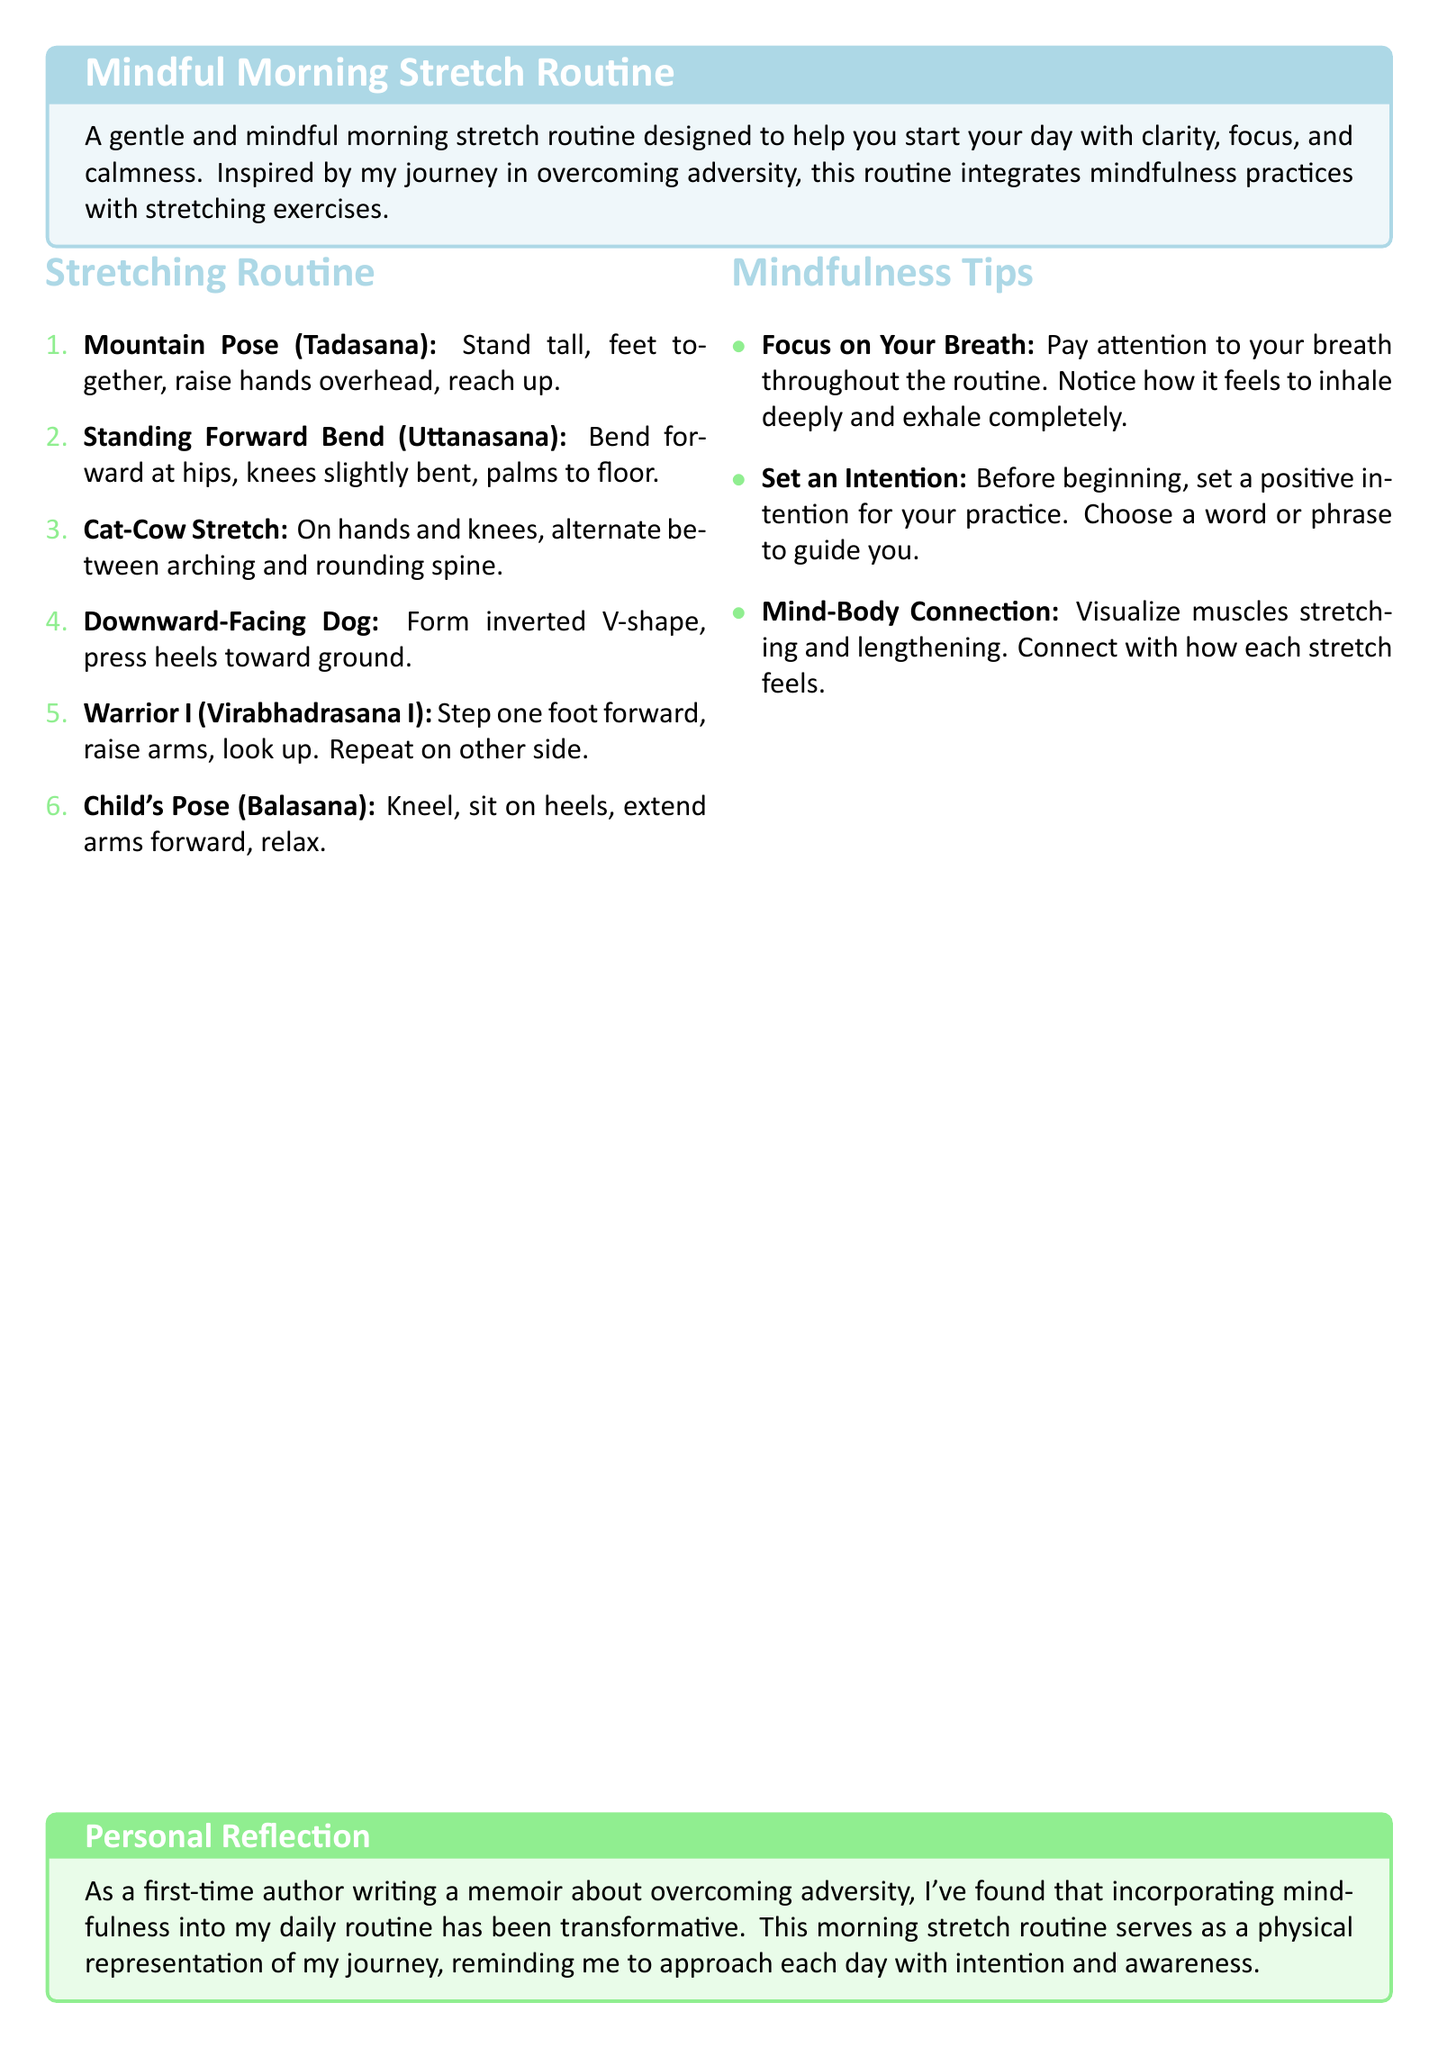What is the title of the routine? The title of the routine is presented in the tcolorbox at the beginning of the document.
Answer: Mindful Morning Stretch Routine How many stretches are included in the routine? The number of stretches is given in the enumerated list of the stretching routine.
Answer: Six What is the first stretch listed in the routine? The first stretch listed corresponds to the first item in the numbered list in the document.
Answer: Mountain Pose (Tadasana) What should you focus on during the routine? The document explicitly mentions an aspect to focus on while performing the stretches.
Answer: Breath What is the color of the tcolorbox for Personal Reflection? The background color of the Personal Reflection tcolorbox is mentioned in the document.
Answer: Mindful green What mindfulness tip involves visualizing muscles? The relevant tip pertains to an action that connects the mind and body through visualization.
Answer: Mind-Body Connection Which pose involves forming an inverted V-shape? The pose is described in the list of stretches and matches the specific description given.
Answer: Downward-Facing Dog How does the author feel about incorporating mindfulness? The author's sentiment towards mindfulness is expressed in the Personal Reflection section.
Answer: Transformative 